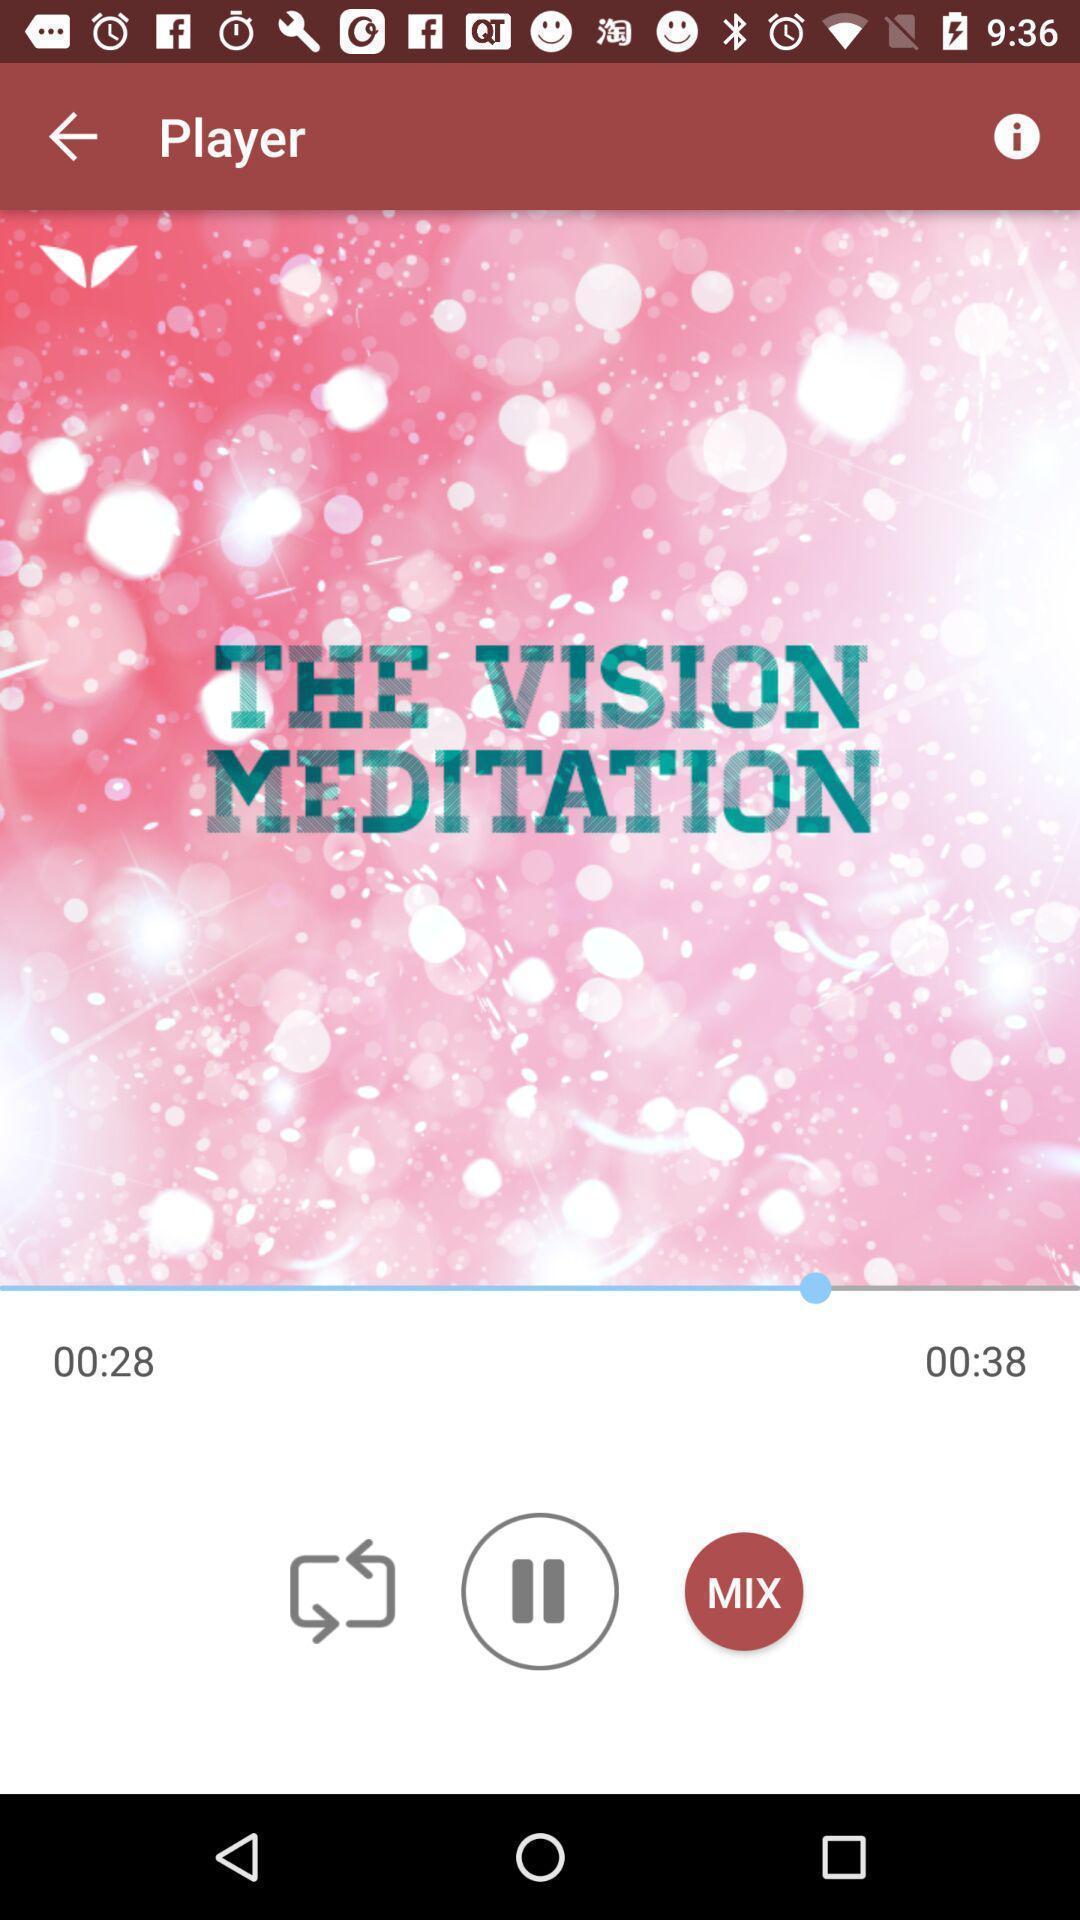Describe the key features of this screenshot. Window displaying with playing music. 